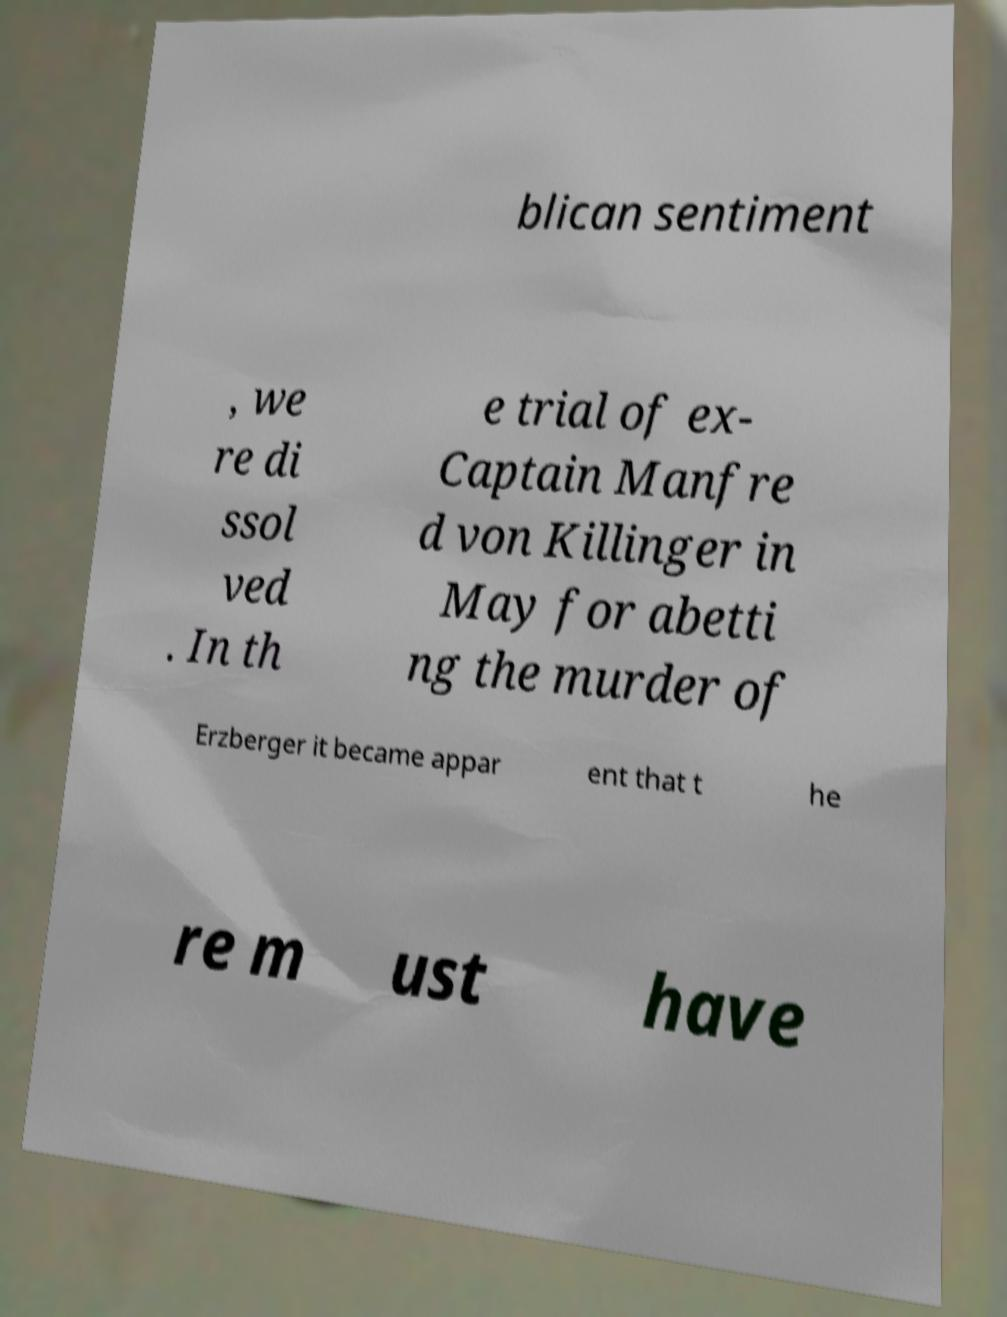There's text embedded in this image that I need extracted. Can you transcribe it verbatim? blican sentiment , we re di ssol ved . In th e trial of ex- Captain Manfre d von Killinger in May for abetti ng the murder of Erzberger it became appar ent that t he re m ust have 